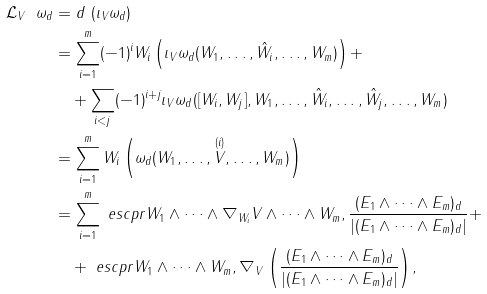<formula> <loc_0><loc_0><loc_500><loc_500>\mathcal { L } _ { V } \ \omega _ { d } & = d \ ( \imath _ { V } \omega _ { d } ) \\ & = \sum _ { i = 1 } ^ { m } ( - 1 ) ^ { i } W _ { i } \left ( \imath _ { V } \omega _ { d } ( W _ { 1 } , \dots , \hat { W } _ { i } , \dots , W _ { m } ) \right ) + \\ & \quad + \sum _ { i < j } ( - 1 ) ^ { i + j } \imath _ { V } \omega _ { d } ( [ W _ { i } , W _ { j } ] , W _ { 1 } , \dots , \hat { W } _ { i } , \dots , \hat { W } _ { j } , \dots , W _ { m } ) \\ & = \sum _ { i = 1 } ^ { m } W _ { i } \left ( \omega _ { d } ( W _ { 1 } , \dots , \overset { ( i ) } { V } , \dots , W _ { m } ) \right ) \\ & = \sum _ { i = 1 } ^ { m } \ e s c p r { W _ { 1 } \wedge \dots \wedge \nabla _ { W _ { i } } V \wedge \dots \wedge W _ { m } , \frac { ( E _ { 1 } \wedge \dots \wedge E _ { m } ) _ { d } } { | ( E _ { 1 } \wedge \dots \wedge E _ { m } ) _ { d } | } } + \\ & \quad + \ e s c p r { W _ { 1 } \wedge \dots \wedge W _ { m } , \nabla _ { V } \left ( \frac { ( E _ { 1 } \wedge \dots \wedge E _ { m } ) _ { d } } { | ( E _ { 1 } \wedge \dots \wedge E _ { m } ) _ { d } | } \right ) } , \\</formula> 